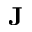Convert formula to latex. <formula><loc_0><loc_0><loc_500><loc_500>{ J }</formula> 